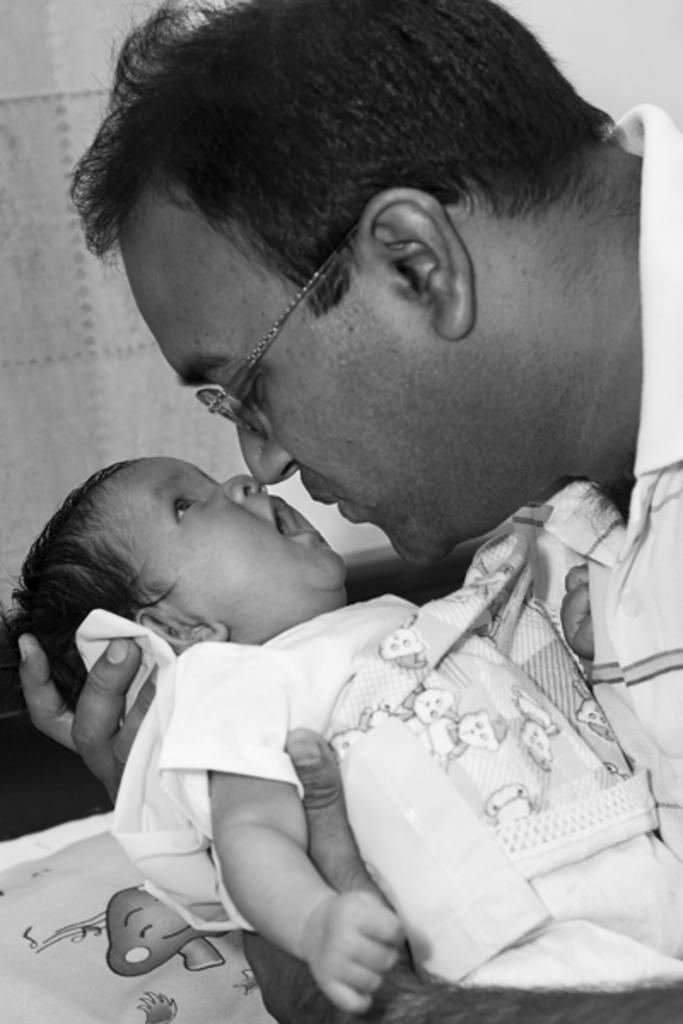What is the color scheme of the image? The image is black and white. What is the person in the image doing? The person is holding a baby in the image. What time of day is it in the image, based on the hour? The provided facts do not mention the time of day or any specific hour, so it cannot be determined from the image. 